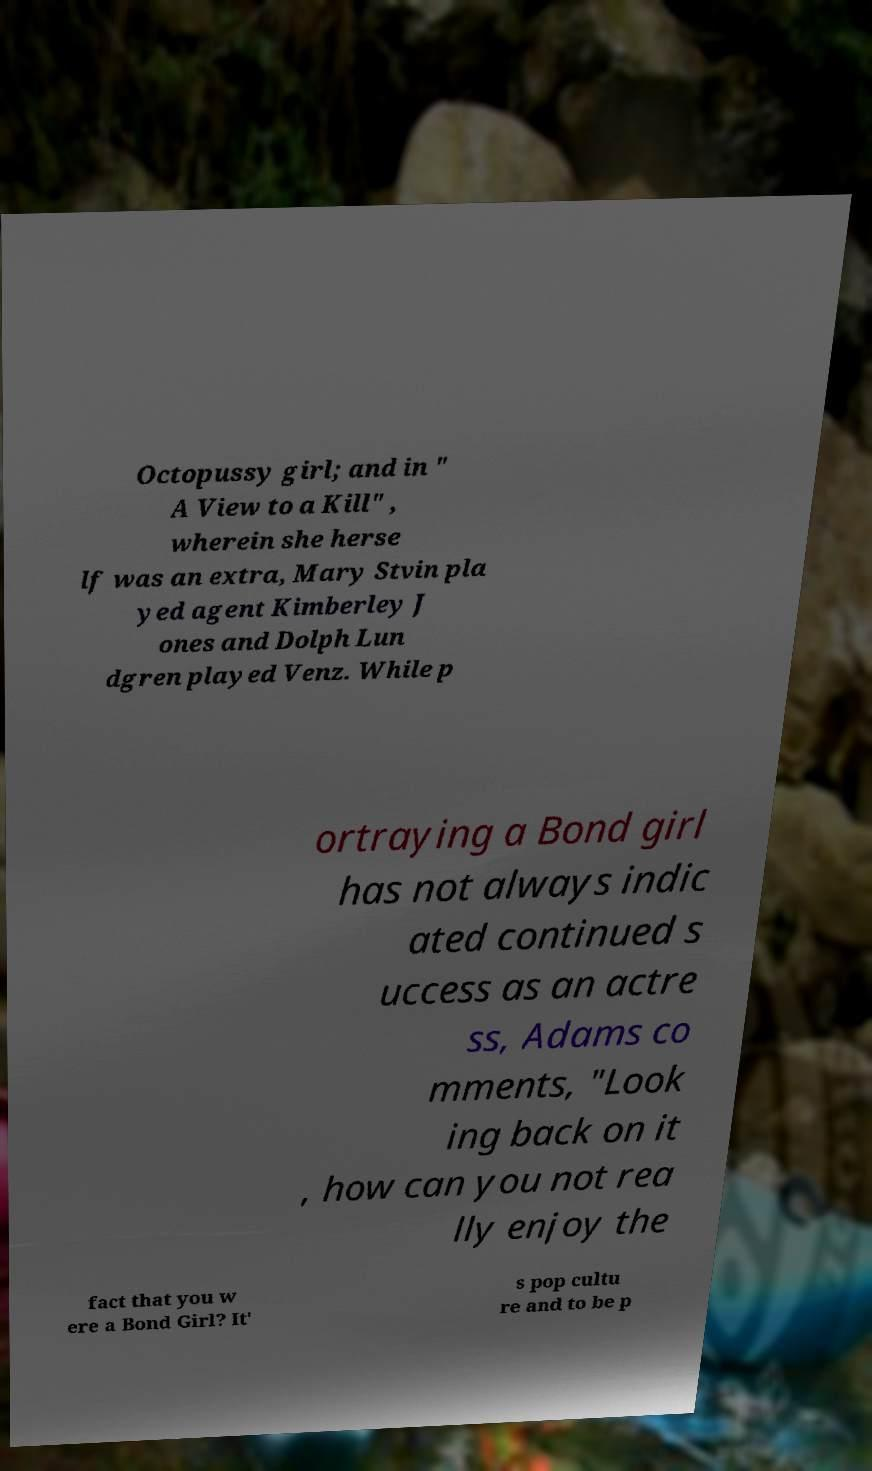Please read and relay the text visible in this image. What does it say? Octopussy girl; and in " A View to a Kill" , wherein she herse lf was an extra, Mary Stvin pla yed agent Kimberley J ones and Dolph Lun dgren played Venz. While p ortraying a Bond girl has not always indic ated continued s uccess as an actre ss, Adams co mments, "Look ing back on it , how can you not rea lly enjoy the fact that you w ere a Bond Girl? It' s pop cultu re and to be p 